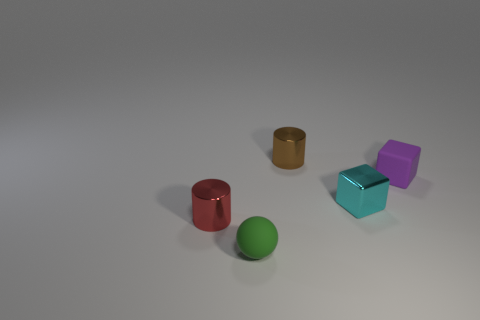How many other purple rubber things are the same size as the purple rubber object?
Ensure brevity in your answer.  0. Is the number of cyan objects that are on the right side of the purple cube less than the number of small cyan metal objects that are to the right of the small cyan shiny block?
Ensure brevity in your answer.  No. What number of matte objects are either tiny cyan cubes or purple blocks?
Keep it short and to the point. 1. There is a tiny cyan metal thing; what shape is it?
Your response must be concise. Cube. There is a cyan thing that is the same size as the green matte object; what material is it?
Offer a very short reply. Metal. How many small objects are either cubes or matte objects?
Your answer should be compact. 3. Is there a small rubber cube?
Give a very brief answer. Yes. The red thing that is the same material as the cyan object is what size?
Your response must be concise. Small. Is the tiny purple thing made of the same material as the green object?
Offer a very short reply. Yes. What number of other objects are the same material as the small purple object?
Your response must be concise. 1. 